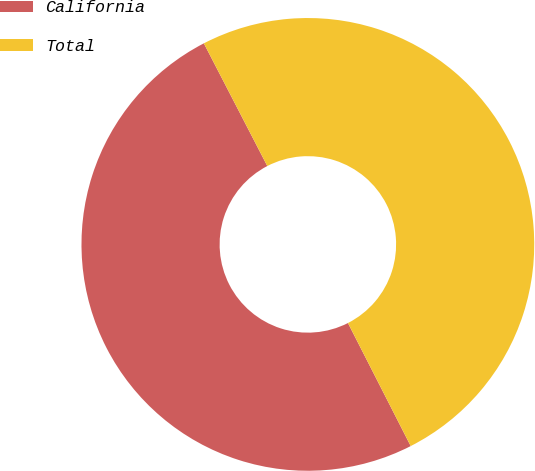Convert chart to OTSL. <chart><loc_0><loc_0><loc_500><loc_500><pie_chart><fcel>California<fcel>Total<nl><fcel>49.91%<fcel>50.09%<nl></chart> 